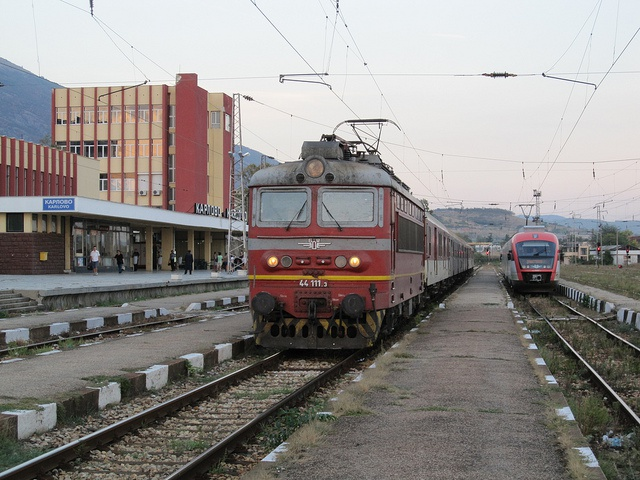Describe the objects in this image and their specific colors. I can see train in white, black, gray, maroon, and darkgray tones, train in white, gray, black, and brown tones, people in white, gray, darkgray, and black tones, people in white, black, and gray tones, and people in white, black, gray, and navy tones in this image. 